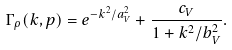Convert formula to latex. <formula><loc_0><loc_0><loc_500><loc_500>\Gamma _ { \rho } ( k , p ) = e ^ { - k ^ { 2 } / a _ { V } ^ { 2 } } + \frac { c _ { V } } { 1 + k ^ { 2 } / b _ { V } ^ { 2 } } .</formula> 